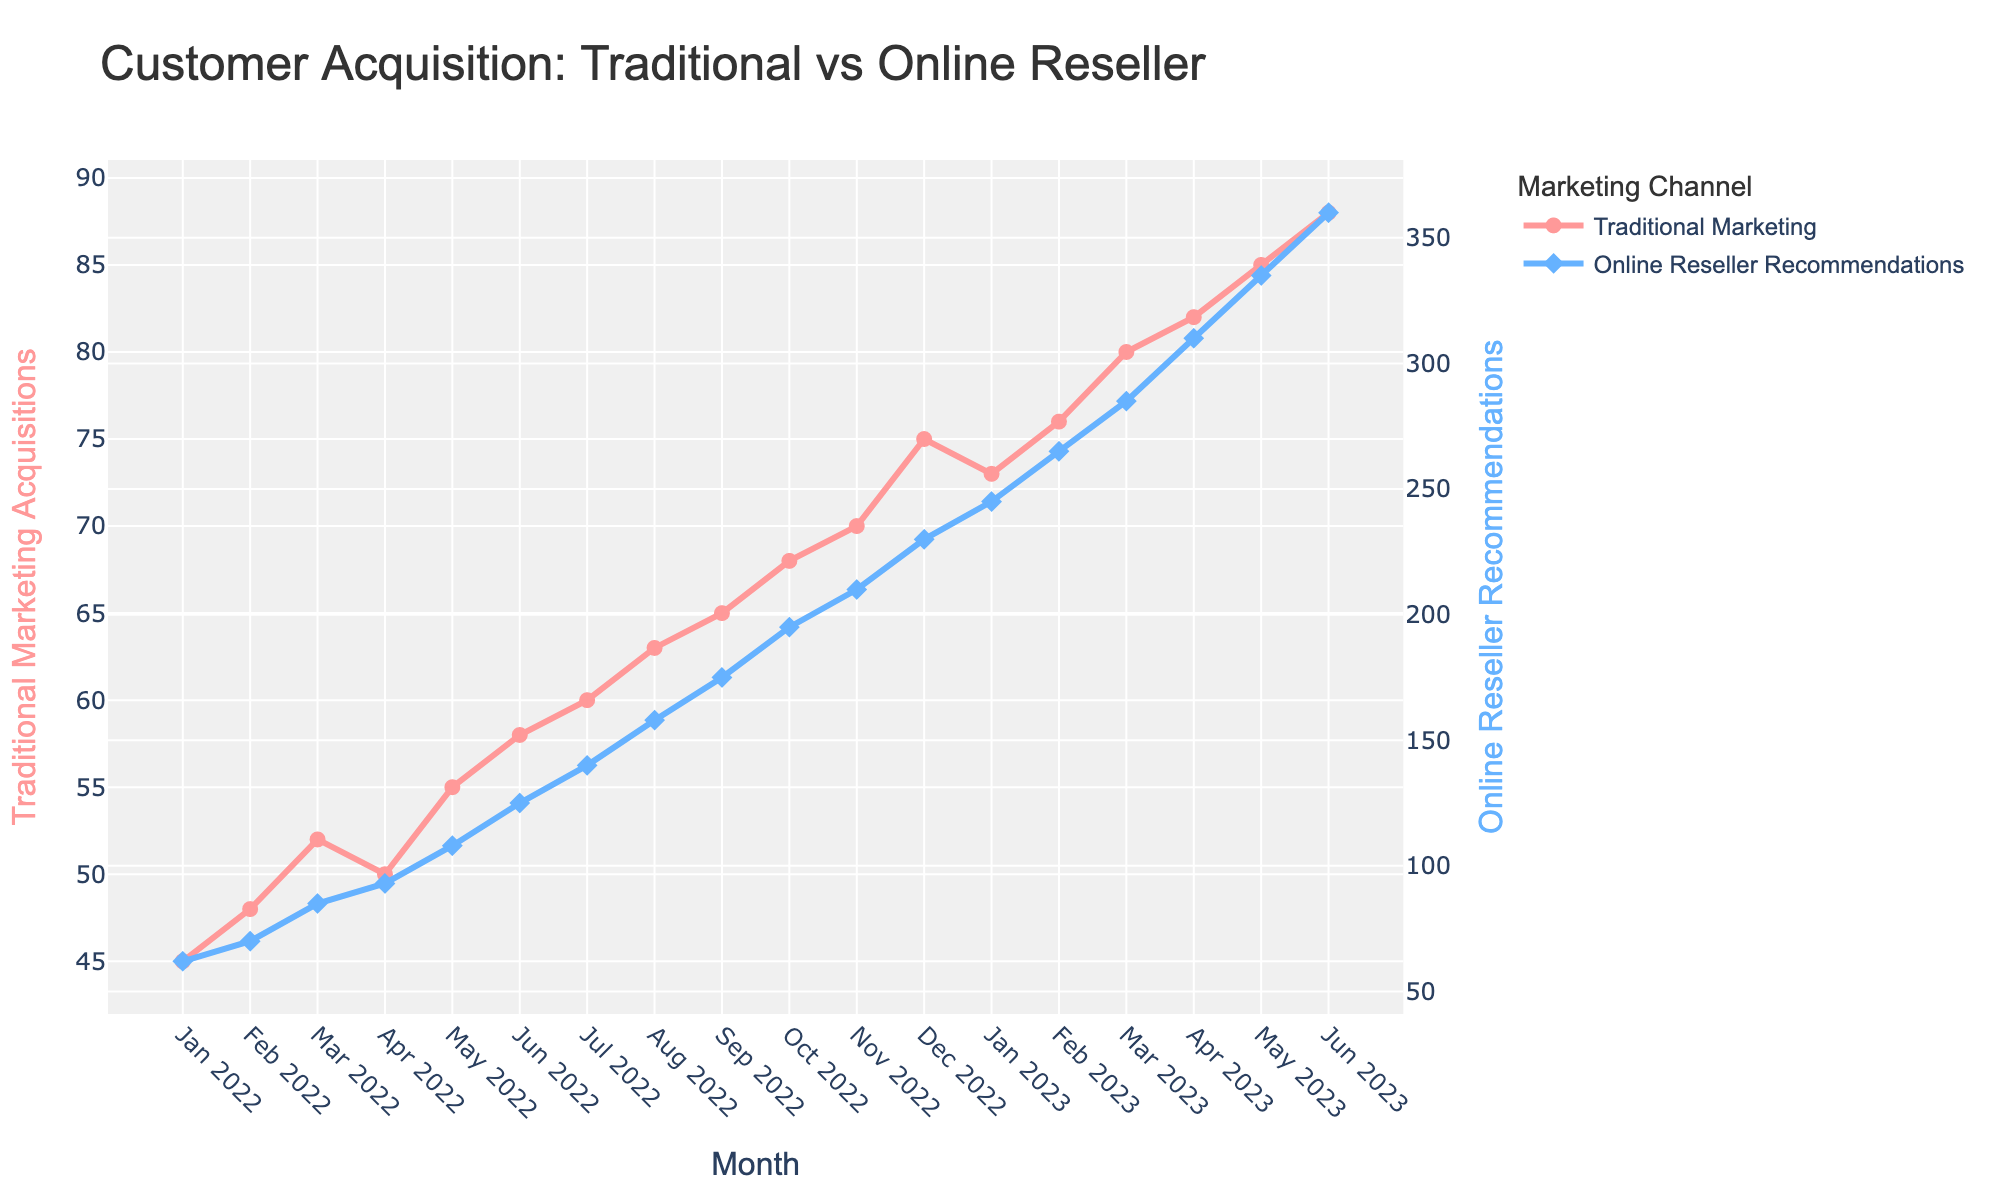Which month shows the highest customer acquisition via Online Reseller Recommendations? By interpreting the data points, the highest customer acquisition for Online Reseller Recommendations is at the final month in the provided data.
Answer: June 2023 What is the difference in customer acquisition between Traditional Marketing and Online Reseller Recommendations in January 2022? Subtract the customer acquisition via Traditional Marketing from that of Online Reseller Recommendations for January 2022 (62 - 45).
Answer: 17 How did the customer acquisition rate via Traditional Marketing change from Feb 2022 to Mar 2022? Look at the values for Feb 2022 (48) and Mar 2022 (52) and calculate the difference (52 - 48).
Answer: Increased by 4 Which marketing channel had a larger increase in customer acquisition from June 2022 to June 2023? Compare the June 2022 and June 2023 acquisition numbers for both Traditional Marketing (58 to 88) and Online Reseller Recommendations (125 to 360), and calculate the differences (88 - 58) and (360 - 125).
Answer: Online Reseller Recommendations What is the average monthly customer acquisition via Traditional Marketing for the entire period? Sum all monthly acquisitions for Traditional Marketing and divide by the number of months: (45 + 48 + 52 + 50 + 55 + 58 + 60 + 63 + 65 + 68 + 70 + 75 + 73 + 76 + 80 + 82 + 85 + 88) / 18. Detailed calculation: (45 + 48 + 52 + 50 + 55 + 58 + 60 + 63 + 65 + 68 + 70 + 75 + 73 + 76 + 80 + 82 + 85 + 88) = 1183, then divide by 18.
Answer: 65.72 In which month did Online Reseller Recommendations see its greatest single-month increase in customer acquisition? Calculate the month-over-month increase for Online Reseller Recommendations and identify the highest value. Max increase comes between Feb 2023 and Mar 2023: from 265 to 285 (20 customers).
Answer: Mar 2023 By how much did the customer acquisition via Online Reseller Recommendations exceed Traditional Marketing in Dec 2022? Subtract the customer acquisition via Traditional Marketing from that of Online Reseller Recommendations for Dec 2022 (230 - 75).
Answer: 155 How many months did it take for Online Reseller Recommendations to consistently surpass 100 customer acquisitions? Identify the month when the acquisition via Online Reseller Recommendations first exceeded 100 and count the months starting from there. It starts consistently exceeding 100 from May 2022.
Answer: 14 months What is the overall trend in customer acquisition via Traditional Marketing over the given period? Observe the general direction of the line representing Traditional Marketing from Jan 2022 to June 2023, which shows a steady increase.
Answer: Steady increase Which month shows the smallest gap between Traditional Marketing and Online Reseller Recommendations customer acquisition rates? Calculate the month-by-month differences and identify the smallest. The smallest difference is in Jan 2022 with a gap of 17 (62 for Online Reseller Recommendations and 45 for Traditional Marketing).
Answer: Jan 2022 